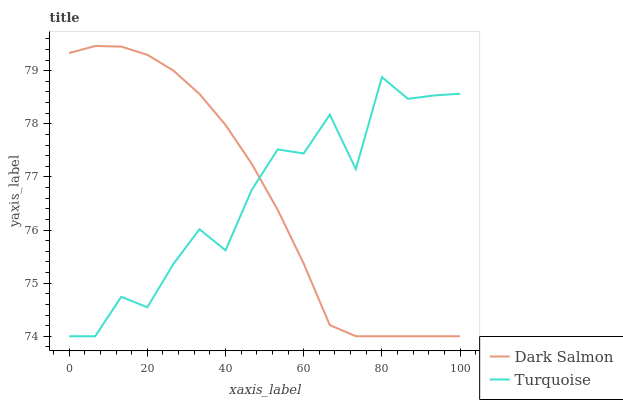Does Turquoise have the minimum area under the curve?
Answer yes or no. Yes. Does Dark Salmon have the maximum area under the curve?
Answer yes or no. Yes. Does Dark Salmon have the minimum area under the curve?
Answer yes or no. No. Is Dark Salmon the smoothest?
Answer yes or no. Yes. Is Turquoise the roughest?
Answer yes or no. Yes. Is Dark Salmon the roughest?
Answer yes or no. No. Does Turquoise have the lowest value?
Answer yes or no. Yes. Does Dark Salmon have the highest value?
Answer yes or no. Yes. Does Turquoise intersect Dark Salmon?
Answer yes or no. Yes. Is Turquoise less than Dark Salmon?
Answer yes or no. No. Is Turquoise greater than Dark Salmon?
Answer yes or no. No. 